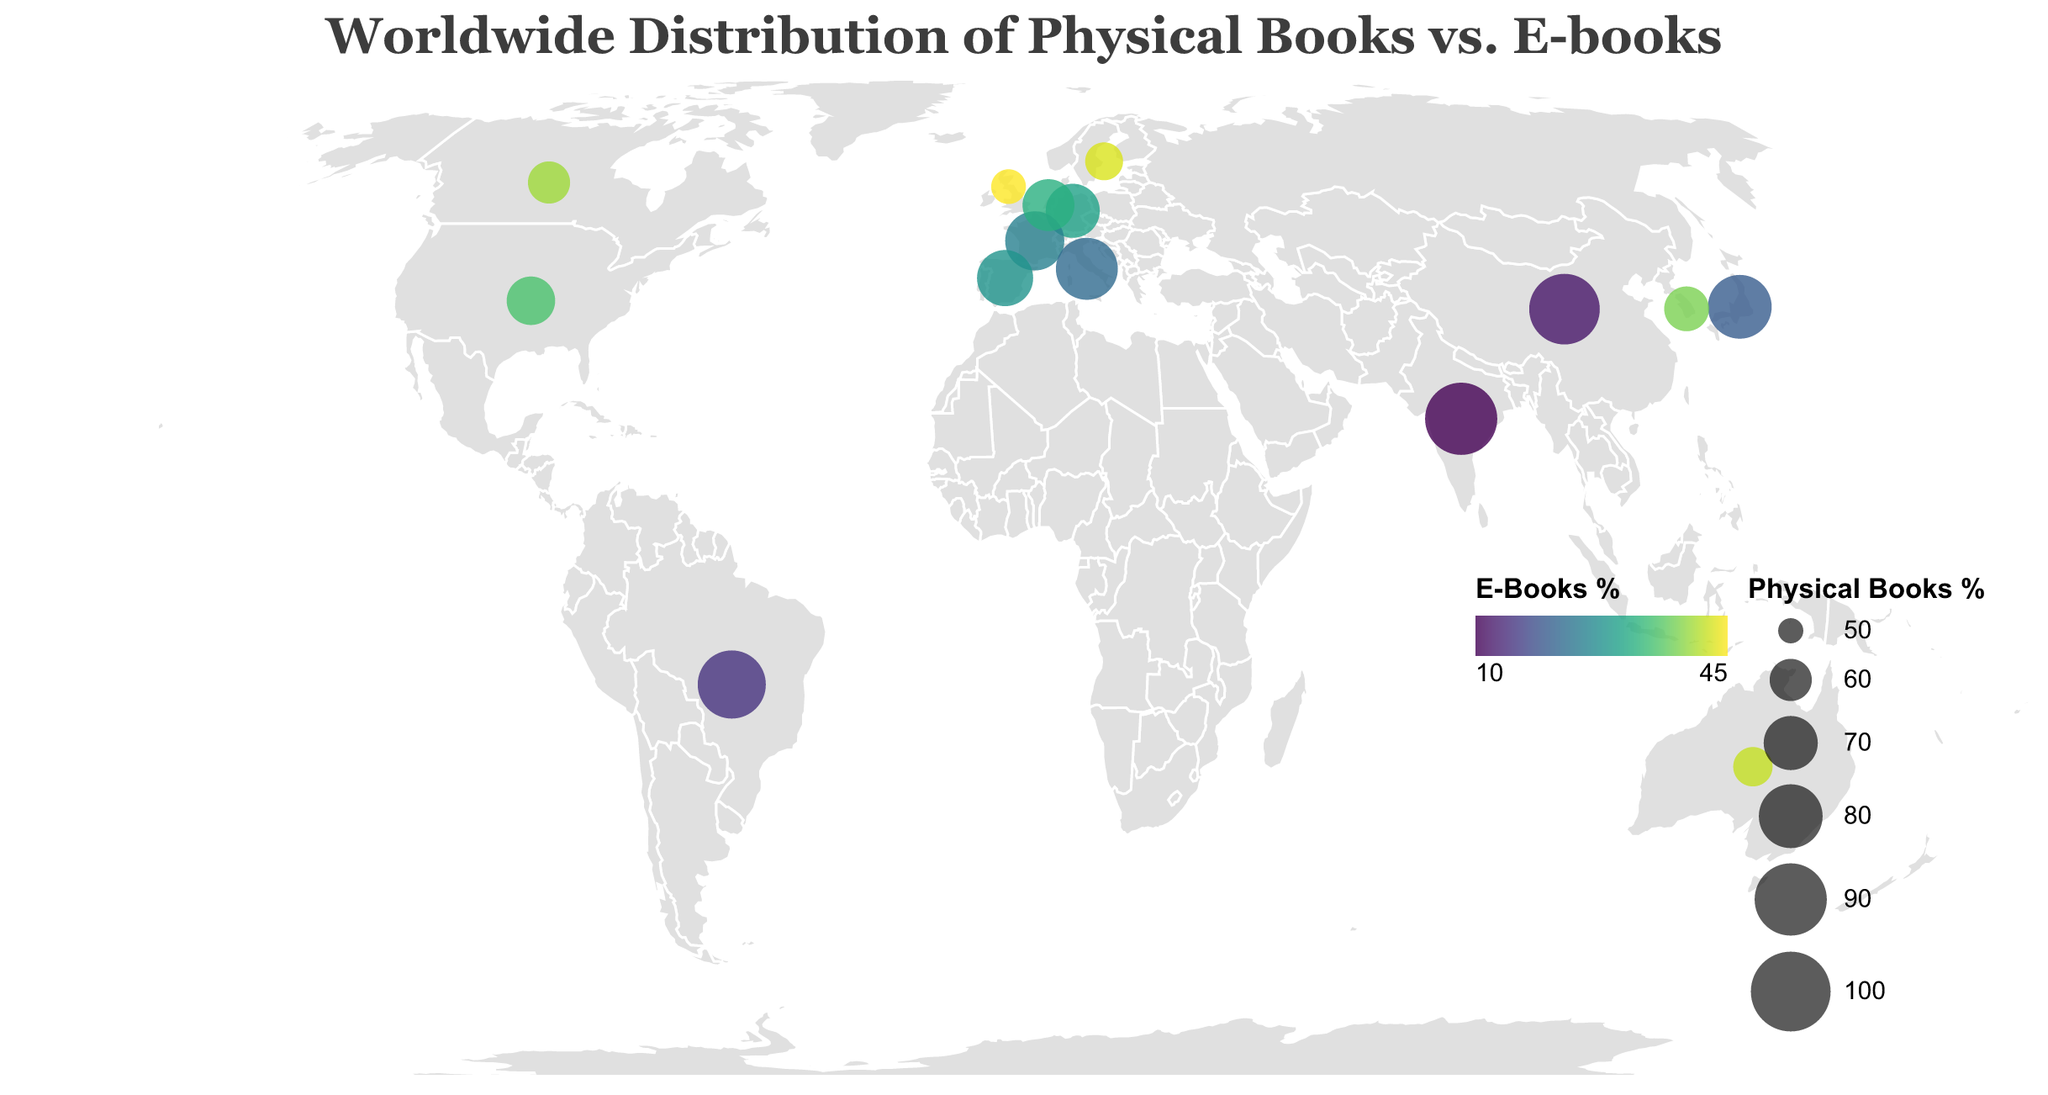Which country has the highest percentage of physical books sales? The tooltip indicates percentage values for each country, showing that India has the highest percentage of physical books sales with 90%.
Answer: India Which country has the lowest percentage of e-books sales? The tooltip shows that India has 10% for e-books, which is the lowest percentage among all countries.
Answer: India How does the percentage of e-books in the United States compare to that in the United Kingdom? By examining the tooltips, we see that the United States has 35% e-books, while the United Kingdom has 45%. The UK has a higher percentage of e-books.
Answer: United Kingdom Which country in Europe has the highest percentage of physical books sales? By looking at the values in Europe (United Kingdom, Germany, France, Italy, Spain, Netherlands, Sweden), Italy has the highest percentage of physical books sales at 78%.
Answer: Italy What can you infer about the relationship between the color intensity and the percentage of e-books? The color legend indicates that darker colors on the viridis scale represent a higher percentage of e-books. Therefore, countries with darker circles have higher e-book percentages.
Answer: Darker color indicates higher percentage of e-books What is the average percentage of physical books sales in Asian countries (India, China, Japan, South Korea)? Add the physical books percentages (90 + 88 + 80 + 62) to get 320, then divide by 4. The average is 320 / 4 = 80%.
Answer: 80% Which country has a similar percentage distribution of physical books and e-books sales as Canada? By comparing the tooltip values, Australia with 58% physical books and 42% e-books is similar to Canada's 60% physical books and 40% e-books.
Answer: Australia How does Brazil's preference for physical books compare to that of China? Brazil's physical books percentage is 85%, and China's is 88%. China has a slightly higher preference for physical books.
Answer: China If the percentage of physical books in the Netherlands increased by 10%, what would be the new percentage? The current percentage for the Netherlands is 68%. Adding 10% gives 68 + 10 = 78%.
Answer: 78% Which country has the smallest circle size, and what does that imply? The smallest circle size corresponds to the country with the lowest percentage of physical books, which is the United Kingdom at 55%. This implies the UK has the lowest physical books percentage among the listed countries.
Answer: United Kingdom 